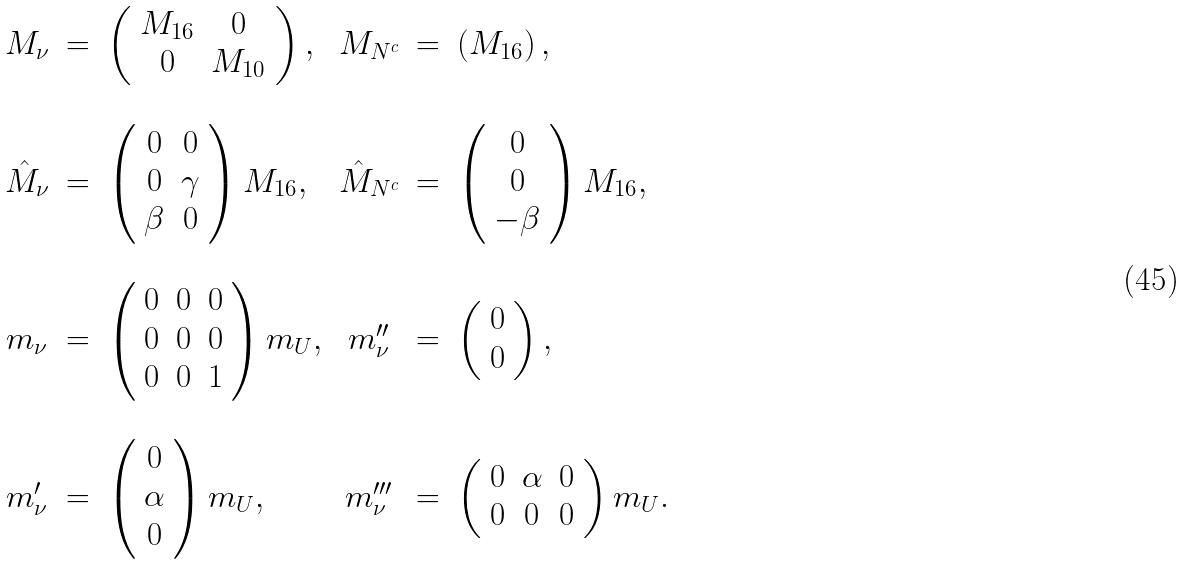<formula> <loc_0><loc_0><loc_500><loc_500>\begin{array} { c c l c c l } M _ { \nu } & = & \left ( \begin{array} { c c } M _ { 1 6 } & 0 \\ 0 & M _ { 1 0 } \end{array} \right ) , & M _ { N ^ { c } } & = & \left ( M _ { 1 6 } \right ) , \\ & & & & & \\ \hat { M } _ { \nu } & = & \left ( \begin{array} { c c } 0 & 0 \\ 0 & \gamma \\ \beta & 0 \end{array} \right ) M _ { 1 6 } , & \hat { M } _ { N ^ { c } } & = & \left ( \begin{array} { c } 0 \\ 0 \\ - \beta \end{array} \right ) M _ { 1 6 } , \\ & & & & & \\ m _ { \nu } & = & \left ( \begin{array} { c c c } 0 & 0 & 0 \\ 0 & 0 & 0 \\ 0 & 0 & 1 \end{array} \right ) m _ { U } , & m ^ { \prime \prime } _ { \nu } & = & \left ( \begin{array} { c } 0 \\ 0 \end{array} \right ) , \\ & & & & & \\ m ^ { \prime } _ { \nu } & = & \left ( \begin{array} { c } 0 \\ \alpha \\ 0 \end{array} \right ) m _ { U } , & m ^ { \prime \prime \prime } _ { \nu } & = & \left ( \begin{array} { c c c } 0 & \alpha & 0 \\ 0 & 0 & 0 \end{array} \right ) m _ { U } . \end{array}</formula> 